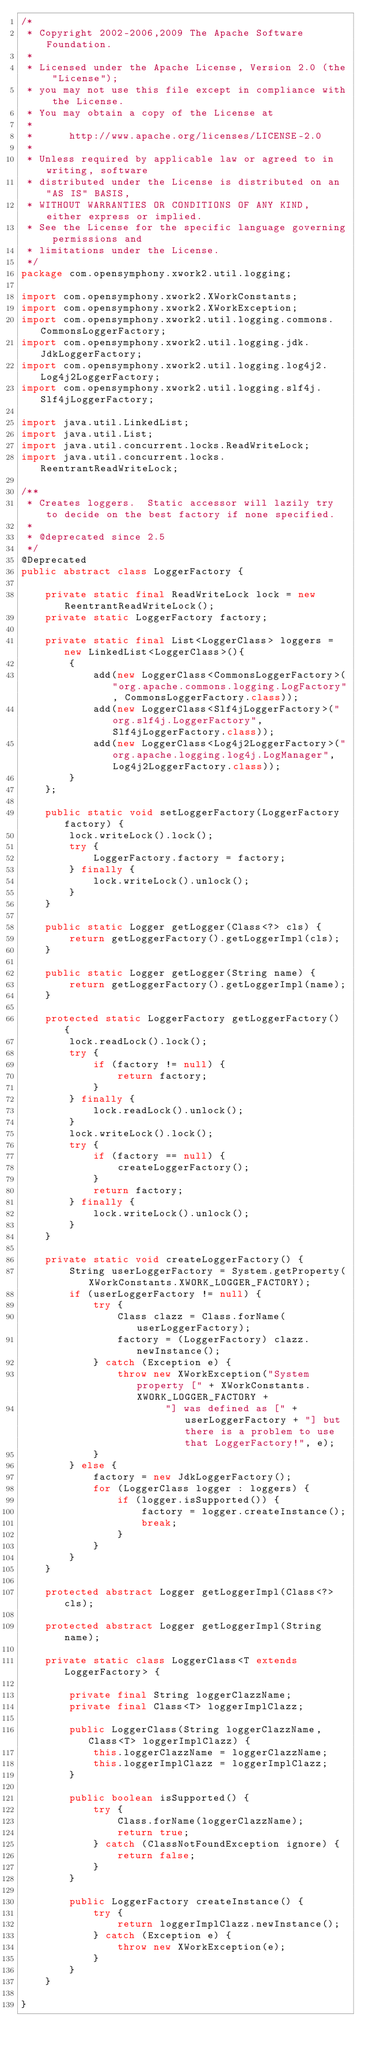<code> <loc_0><loc_0><loc_500><loc_500><_Java_>/*
 * Copyright 2002-2006,2009 The Apache Software Foundation.
 * 
 * Licensed under the Apache License, Version 2.0 (the "License");
 * you may not use this file except in compliance with the License.
 * You may obtain a copy of the License at
 * 
 *      http://www.apache.org/licenses/LICENSE-2.0
 * 
 * Unless required by applicable law or agreed to in writing, software
 * distributed under the License is distributed on an "AS IS" BASIS,
 * WITHOUT WARRANTIES OR CONDITIONS OF ANY KIND, either express or implied.
 * See the License for the specific language governing permissions and
 * limitations under the License.
 */
package com.opensymphony.xwork2.util.logging;

import com.opensymphony.xwork2.XWorkConstants;
import com.opensymphony.xwork2.XWorkException;
import com.opensymphony.xwork2.util.logging.commons.CommonsLoggerFactory;
import com.opensymphony.xwork2.util.logging.jdk.JdkLoggerFactory;
import com.opensymphony.xwork2.util.logging.log4j2.Log4j2LoggerFactory;
import com.opensymphony.xwork2.util.logging.slf4j.Slf4jLoggerFactory;

import java.util.LinkedList;
import java.util.List;
import java.util.concurrent.locks.ReadWriteLock;
import java.util.concurrent.locks.ReentrantReadWriteLock;

/**
 * Creates loggers.  Static accessor will lazily try to decide on the best factory if none specified.
 *
 * @deprecated since 2.5
 */
@Deprecated
public abstract class LoggerFactory {

    private static final ReadWriteLock lock = new ReentrantReadWriteLock();
    private static LoggerFactory factory;

    private static final List<LoggerClass> loggers = new LinkedList<LoggerClass>(){
        {
            add(new LoggerClass<CommonsLoggerFactory>("org.apache.commons.logging.LogFactory", CommonsLoggerFactory.class));
            add(new LoggerClass<Slf4jLoggerFactory>("org.slf4j.LoggerFactory", Slf4jLoggerFactory.class));
            add(new LoggerClass<Log4j2LoggerFactory>("org.apache.logging.log4j.LogManager", Log4j2LoggerFactory.class));
        }
    };

    public static void setLoggerFactory(LoggerFactory factory) {
        lock.writeLock().lock();
        try {
            LoggerFactory.factory = factory;
        } finally {
            lock.writeLock().unlock();
        }
    }

    public static Logger getLogger(Class<?> cls) {
        return getLoggerFactory().getLoggerImpl(cls);
    }

    public static Logger getLogger(String name) {
        return getLoggerFactory().getLoggerImpl(name);
    }

    protected static LoggerFactory getLoggerFactory() {
        lock.readLock().lock();
        try {
            if (factory != null) {
                return factory;
            }
        } finally {
            lock.readLock().unlock();
        }
        lock.writeLock().lock();
        try {
            if (factory == null) {
                createLoggerFactory();
            }
            return factory;
        } finally {
            lock.writeLock().unlock();
        }
    }

    private static void createLoggerFactory() {
        String userLoggerFactory = System.getProperty(XWorkConstants.XWORK_LOGGER_FACTORY);
        if (userLoggerFactory != null) {
            try {
                Class clazz = Class.forName(userLoggerFactory);
                factory = (LoggerFactory) clazz.newInstance();
            } catch (Exception e) {
                throw new XWorkException("System property [" + XWorkConstants.XWORK_LOGGER_FACTORY +
                        "] was defined as [" + userLoggerFactory + "] but there is a problem to use that LoggerFactory!", e);
            }
        } else {
            factory = new JdkLoggerFactory();
            for (LoggerClass logger : loggers) {
                if (logger.isSupported()) {
                    factory = logger.createInstance();
                    break;
                }
            }
        }
    }

    protected abstract Logger getLoggerImpl(Class<?> cls);

    protected abstract Logger getLoggerImpl(String name);

    private static class LoggerClass<T extends LoggerFactory> {

        private final String loggerClazzName;
        private final Class<T> loggerImplClazz;

        public LoggerClass(String loggerClazzName, Class<T> loggerImplClazz) {
            this.loggerClazzName = loggerClazzName;
            this.loggerImplClazz = loggerImplClazz;
        }

        public boolean isSupported() {
            try {
                Class.forName(loggerClazzName);
                return true;
            } catch (ClassNotFoundException ignore) {
                return false;
            }
        }

        public LoggerFactory createInstance() {
            try {
                return loggerImplClazz.newInstance();
            } catch (Exception e) {
                throw new XWorkException(e);
            }
        }
    }

}
</code> 